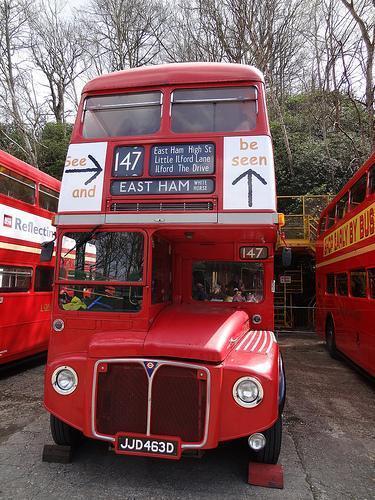How many numbers are on the license plate?
Give a very brief answer. 3. 